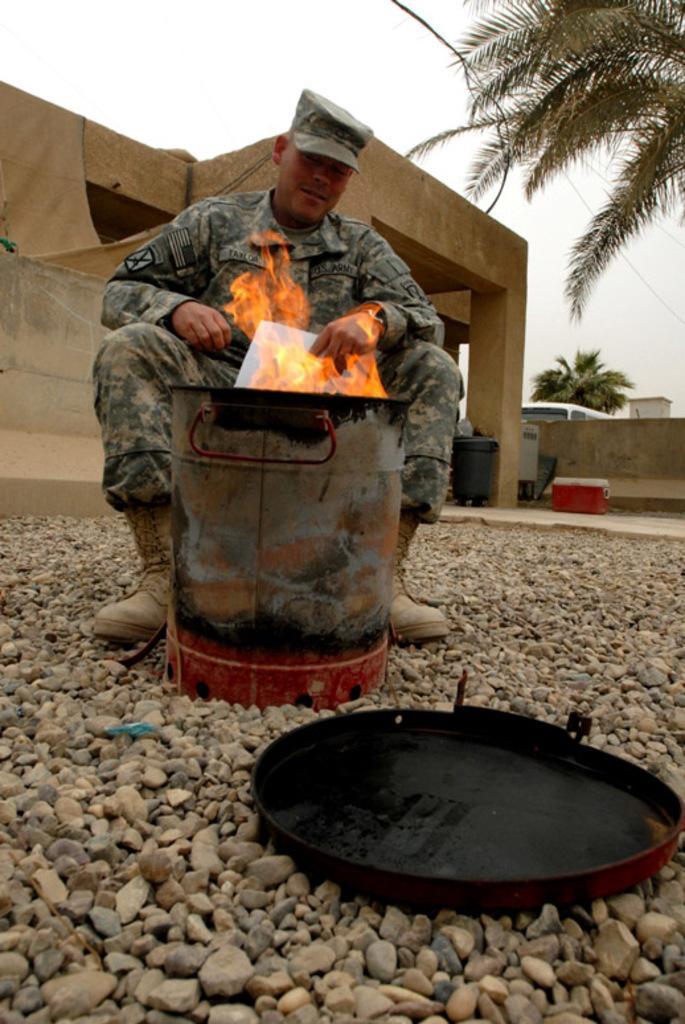Please provide a concise description of this image. In this picture we can see a man wore a cap and holding a paper with his hand. In front of him we can see an object, lid, fire and stones. In the background we can see a box, vehicle, vin, walls, cloth, buildings, trees and the sky. 